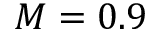Convert formula to latex. <formula><loc_0><loc_0><loc_500><loc_500>M = 0 . 9</formula> 